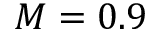Convert formula to latex. <formula><loc_0><loc_0><loc_500><loc_500>M = 0 . 9</formula> 